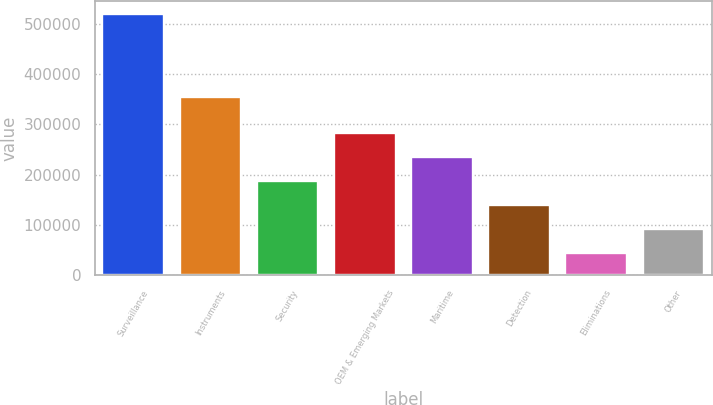<chart> <loc_0><loc_0><loc_500><loc_500><bar_chart><fcel>Surveillance<fcel>Instruments<fcel>Security<fcel>OEM & Emerging Markets<fcel>Maritime<fcel>Detection<fcel>Eliminations<fcel>Other<nl><fcel>519982<fcel>354124<fcel>187429<fcel>282444<fcel>234936<fcel>139921<fcel>44906<fcel>92413.6<nl></chart> 